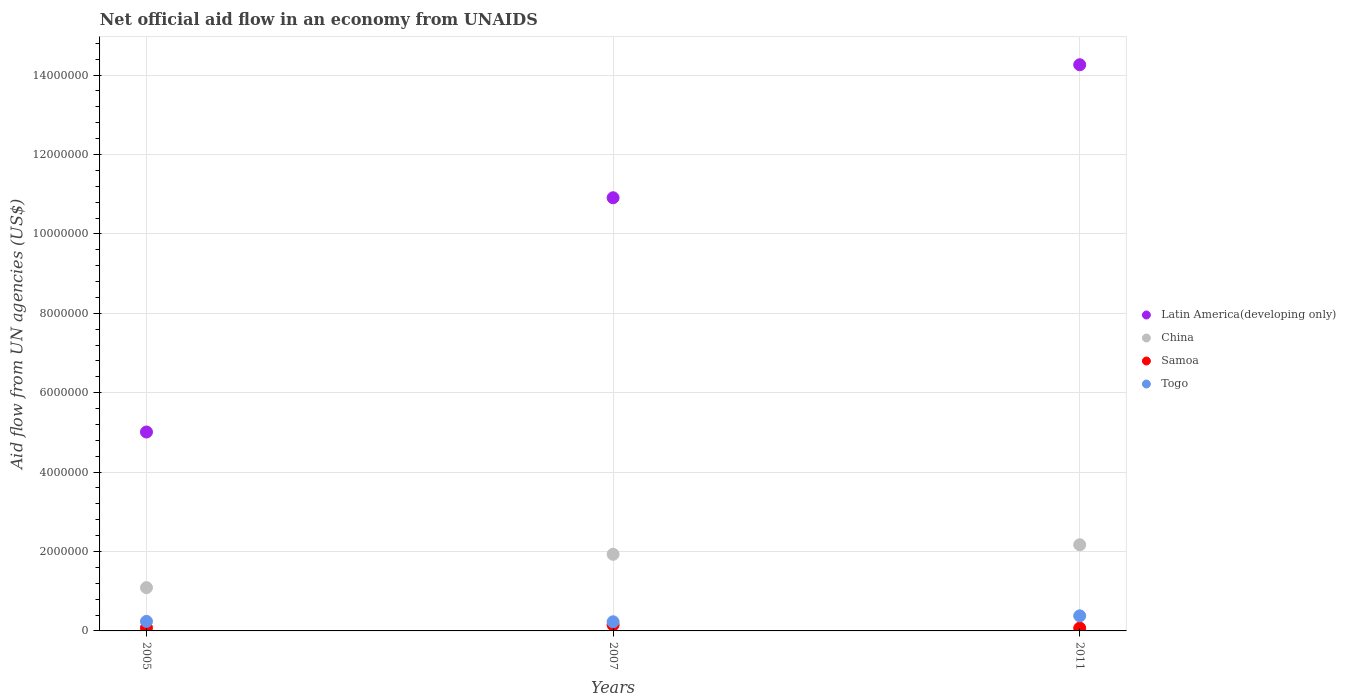How many different coloured dotlines are there?
Offer a terse response. 4. What is the net official aid flow in Latin America(developing only) in 2007?
Your answer should be very brief. 1.09e+07. Across all years, what is the maximum net official aid flow in China?
Your response must be concise. 2.17e+06. Across all years, what is the minimum net official aid flow in Togo?
Give a very brief answer. 2.30e+05. In which year was the net official aid flow in Latin America(developing only) minimum?
Provide a short and direct response. 2005. What is the total net official aid flow in Latin America(developing only) in the graph?
Your answer should be compact. 3.02e+07. What is the difference between the net official aid flow in Togo in 2007 and that in 2011?
Provide a succinct answer. -1.50e+05. What is the difference between the net official aid flow in China in 2011 and the net official aid flow in Togo in 2007?
Ensure brevity in your answer.  1.94e+06. What is the average net official aid flow in China per year?
Your answer should be very brief. 1.73e+06. In the year 2005, what is the difference between the net official aid flow in Togo and net official aid flow in Latin America(developing only)?
Your answer should be very brief. -4.77e+06. In how many years, is the net official aid flow in Samoa greater than 13200000 US$?
Offer a very short reply. 0. What is the ratio of the net official aid flow in Samoa in 2005 to that in 2011?
Your response must be concise. 1.14. Is the difference between the net official aid flow in Togo in 2007 and 2011 greater than the difference between the net official aid flow in Latin America(developing only) in 2007 and 2011?
Provide a short and direct response. Yes. What is the difference between the highest and the second highest net official aid flow in Latin America(developing only)?
Offer a very short reply. 3.35e+06. What is the difference between the highest and the lowest net official aid flow in Latin America(developing only)?
Offer a terse response. 9.25e+06. In how many years, is the net official aid flow in China greater than the average net official aid flow in China taken over all years?
Offer a very short reply. 2. Is it the case that in every year, the sum of the net official aid flow in Samoa and net official aid flow in Togo  is greater than the sum of net official aid flow in Latin America(developing only) and net official aid flow in China?
Ensure brevity in your answer.  No. Is it the case that in every year, the sum of the net official aid flow in Latin America(developing only) and net official aid flow in China  is greater than the net official aid flow in Samoa?
Give a very brief answer. Yes. Is the net official aid flow in Samoa strictly greater than the net official aid flow in Latin America(developing only) over the years?
Provide a short and direct response. No. How many years are there in the graph?
Ensure brevity in your answer.  3. What is the difference between two consecutive major ticks on the Y-axis?
Make the answer very short. 2.00e+06. Does the graph contain any zero values?
Offer a terse response. No. Does the graph contain grids?
Provide a short and direct response. Yes. How many legend labels are there?
Make the answer very short. 4. How are the legend labels stacked?
Give a very brief answer. Vertical. What is the title of the graph?
Your response must be concise. Net official aid flow in an economy from UNAIDS. What is the label or title of the X-axis?
Offer a very short reply. Years. What is the label or title of the Y-axis?
Make the answer very short. Aid flow from UN agencies (US$). What is the Aid flow from UN agencies (US$) of Latin America(developing only) in 2005?
Make the answer very short. 5.01e+06. What is the Aid flow from UN agencies (US$) of China in 2005?
Provide a short and direct response. 1.09e+06. What is the Aid flow from UN agencies (US$) in Togo in 2005?
Give a very brief answer. 2.40e+05. What is the Aid flow from UN agencies (US$) in Latin America(developing only) in 2007?
Give a very brief answer. 1.09e+07. What is the Aid flow from UN agencies (US$) of China in 2007?
Offer a terse response. 1.93e+06. What is the Aid flow from UN agencies (US$) of Samoa in 2007?
Offer a terse response. 1.50e+05. What is the Aid flow from UN agencies (US$) of Latin America(developing only) in 2011?
Your answer should be very brief. 1.43e+07. What is the Aid flow from UN agencies (US$) of China in 2011?
Your answer should be very brief. 2.17e+06. Across all years, what is the maximum Aid flow from UN agencies (US$) in Latin America(developing only)?
Make the answer very short. 1.43e+07. Across all years, what is the maximum Aid flow from UN agencies (US$) of China?
Keep it short and to the point. 2.17e+06. Across all years, what is the maximum Aid flow from UN agencies (US$) of Samoa?
Make the answer very short. 1.50e+05. Across all years, what is the maximum Aid flow from UN agencies (US$) of Togo?
Your answer should be compact. 3.80e+05. Across all years, what is the minimum Aid flow from UN agencies (US$) of Latin America(developing only)?
Your answer should be very brief. 5.01e+06. Across all years, what is the minimum Aid flow from UN agencies (US$) in China?
Offer a very short reply. 1.09e+06. Across all years, what is the minimum Aid flow from UN agencies (US$) of Samoa?
Offer a terse response. 7.00e+04. Across all years, what is the minimum Aid flow from UN agencies (US$) in Togo?
Provide a short and direct response. 2.30e+05. What is the total Aid flow from UN agencies (US$) in Latin America(developing only) in the graph?
Your answer should be very brief. 3.02e+07. What is the total Aid flow from UN agencies (US$) of China in the graph?
Provide a short and direct response. 5.19e+06. What is the total Aid flow from UN agencies (US$) in Samoa in the graph?
Make the answer very short. 3.00e+05. What is the total Aid flow from UN agencies (US$) in Togo in the graph?
Your response must be concise. 8.50e+05. What is the difference between the Aid flow from UN agencies (US$) in Latin America(developing only) in 2005 and that in 2007?
Provide a short and direct response. -5.90e+06. What is the difference between the Aid flow from UN agencies (US$) in China in 2005 and that in 2007?
Offer a terse response. -8.40e+05. What is the difference between the Aid flow from UN agencies (US$) in Togo in 2005 and that in 2007?
Give a very brief answer. 10000. What is the difference between the Aid flow from UN agencies (US$) in Latin America(developing only) in 2005 and that in 2011?
Your answer should be compact. -9.25e+06. What is the difference between the Aid flow from UN agencies (US$) in China in 2005 and that in 2011?
Keep it short and to the point. -1.08e+06. What is the difference between the Aid flow from UN agencies (US$) of Togo in 2005 and that in 2011?
Your response must be concise. -1.40e+05. What is the difference between the Aid flow from UN agencies (US$) of Latin America(developing only) in 2007 and that in 2011?
Provide a succinct answer. -3.35e+06. What is the difference between the Aid flow from UN agencies (US$) in Latin America(developing only) in 2005 and the Aid flow from UN agencies (US$) in China in 2007?
Keep it short and to the point. 3.08e+06. What is the difference between the Aid flow from UN agencies (US$) in Latin America(developing only) in 2005 and the Aid flow from UN agencies (US$) in Samoa in 2007?
Your answer should be very brief. 4.86e+06. What is the difference between the Aid flow from UN agencies (US$) in Latin America(developing only) in 2005 and the Aid flow from UN agencies (US$) in Togo in 2007?
Make the answer very short. 4.78e+06. What is the difference between the Aid flow from UN agencies (US$) in China in 2005 and the Aid flow from UN agencies (US$) in Samoa in 2007?
Offer a very short reply. 9.40e+05. What is the difference between the Aid flow from UN agencies (US$) in China in 2005 and the Aid flow from UN agencies (US$) in Togo in 2007?
Your answer should be very brief. 8.60e+05. What is the difference between the Aid flow from UN agencies (US$) of Samoa in 2005 and the Aid flow from UN agencies (US$) of Togo in 2007?
Your answer should be compact. -1.50e+05. What is the difference between the Aid flow from UN agencies (US$) in Latin America(developing only) in 2005 and the Aid flow from UN agencies (US$) in China in 2011?
Give a very brief answer. 2.84e+06. What is the difference between the Aid flow from UN agencies (US$) in Latin America(developing only) in 2005 and the Aid flow from UN agencies (US$) in Samoa in 2011?
Offer a terse response. 4.94e+06. What is the difference between the Aid flow from UN agencies (US$) in Latin America(developing only) in 2005 and the Aid flow from UN agencies (US$) in Togo in 2011?
Your answer should be very brief. 4.63e+06. What is the difference between the Aid flow from UN agencies (US$) of China in 2005 and the Aid flow from UN agencies (US$) of Samoa in 2011?
Ensure brevity in your answer.  1.02e+06. What is the difference between the Aid flow from UN agencies (US$) of China in 2005 and the Aid flow from UN agencies (US$) of Togo in 2011?
Keep it short and to the point. 7.10e+05. What is the difference between the Aid flow from UN agencies (US$) in Samoa in 2005 and the Aid flow from UN agencies (US$) in Togo in 2011?
Keep it short and to the point. -3.00e+05. What is the difference between the Aid flow from UN agencies (US$) in Latin America(developing only) in 2007 and the Aid flow from UN agencies (US$) in China in 2011?
Provide a short and direct response. 8.74e+06. What is the difference between the Aid flow from UN agencies (US$) in Latin America(developing only) in 2007 and the Aid flow from UN agencies (US$) in Samoa in 2011?
Offer a very short reply. 1.08e+07. What is the difference between the Aid flow from UN agencies (US$) of Latin America(developing only) in 2007 and the Aid flow from UN agencies (US$) of Togo in 2011?
Ensure brevity in your answer.  1.05e+07. What is the difference between the Aid flow from UN agencies (US$) of China in 2007 and the Aid flow from UN agencies (US$) of Samoa in 2011?
Give a very brief answer. 1.86e+06. What is the difference between the Aid flow from UN agencies (US$) in China in 2007 and the Aid flow from UN agencies (US$) in Togo in 2011?
Your response must be concise. 1.55e+06. What is the difference between the Aid flow from UN agencies (US$) of Samoa in 2007 and the Aid flow from UN agencies (US$) of Togo in 2011?
Provide a short and direct response. -2.30e+05. What is the average Aid flow from UN agencies (US$) in Latin America(developing only) per year?
Provide a succinct answer. 1.01e+07. What is the average Aid flow from UN agencies (US$) of China per year?
Make the answer very short. 1.73e+06. What is the average Aid flow from UN agencies (US$) of Togo per year?
Provide a short and direct response. 2.83e+05. In the year 2005, what is the difference between the Aid flow from UN agencies (US$) in Latin America(developing only) and Aid flow from UN agencies (US$) in China?
Ensure brevity in your answer.  3.92e+06. In the year 2005, what is the difference between the Aid flow from UN agencies (US$) of Latin America(developing only) and Aid flow from UN agencies (US$) of Samoa?
Offer a very short reply. 4.93e+06. In the year 2005, what is the difference between the Aid flow from UN agencies (US$) in Latin America(developing only) and Aid flow from UN agencies (US$) in Togo?
Your answer should be very brief. 4.77e+06. In the year 2005, what is the difference between the Aid flow from UN agencies (US$) of China and Aid flow from UN agencies (US$) of Samoa?
Provide a short and direct response. 1.01e+06. In the year 2005, what is the difference between the Aid flow from UN agencies (US$) in China and Aid flow from UN agencies (US$) in Togo?
Give a very brief answer. 8.50e+05. In the year 2005, what is the difference between the Aid flow from UN agencies (US$) in Samoa and Aid flow from UN agencies (US$) in Togo?
Keep it short and to the point. -1.60e+05. In the year 2007, what is the difference between the Aid flow from UN agencies (US$) in Latin America(developing only) and Aid flow from UN agencies (US$) in China?
Ensure brevity in your answer.  8.98e+06. In the year 2007, what is the difference between the Aid flow from UN agencies (US$) in Latin America(developing only) and Aid flow from UN agencies (US$) in Samoa?
Keep it short and to the point. 1.08e+07. In the year 2007, what is the difference between the Aid flow from UN agencies (US$) of Latin America(developing only) and Aid flow from UN agencies (US$) of Togo?
Ensure brevity in your answer.  1.07e+07. In the year 2007, what is the difference between the Aid flow from UN agencies (US$) in China and Aid flow from UN agencies (US$) in Samoa?
Offer a terse response. 1.78e+06. In the year 2007, what is the difference between the Aid flow from UN agencies (US$) of China and Aid flow from UN agencies (US$) of Togo?
Offer a terse response. 1.70e+06. In the year 2011, what is the difference between the Aid flow from UN agencies (US$) of Latin America(developing only) and Aid flow from UN agencies (US$) of China?
Give a very brief answer. 1.21e+07. In the year 2011, what is the difference between the Aid flow from UN agencies (US$) of Latin America(developing only) and Aid flow from UN agencies (US$) of Samoa?
Give a very brief answer. 1.42e+07. In the year 2011, what is the difference between the Aid flow from UN agencies (US$) of Latin America(developing only) and Aid flow from UN agencies (US$) of Togo?
Provide a short and direct response. 1.39e+07. In the year 2011, what is the difference between the Aid flow from UN agencies (US$) in China and Aid flow from UN agencies (US$) in Samoa?
Provide a short and direct response. 2.10e+06. In the year 2011, what is the difference between the Aid flow from UN agencies (US$) of China and Aid flow from UN agencies (US$) of Togo?
Keep it short and to the point. 1.79e+06. In the year 2011, what is the difference between the Aid flow from UN agencies (US$) of Samoa and Aid flow from UN agencies (US$) of Togo?
Offer a very short reply. -3.10e+05. What is the ratio of the Aid flow from UN agencies (US$) of Latin America(developing only) in 2005 to that in 2007?
Provide a succinct answer. 0.46. What is the ratio of the Aid flow from UN agencies (US$) in China in 2005 to that in 2007?
Provide a succinct answer. 0.56. What is the ratio of the Aid flow from UN agencies (US$) of Samoa in 2005 to that in 2007?
Your answer should be compact. 0.53. What is the ratio of the Aid flow from UN agencies (US$) in Togo in 2005 to that in 2007?
Make the answer very short. 1.04. What is the ratio of the Aid flow from UN agencies (US$) of Latin America(developing only) in 2005 to that in 2011?
Provide a succinct answer. 0.35. What is the ratio of the Aid flow from UN agencies (US$) in China in 2005 to that in 2011?
Your answer should be very brief. 0.5. What is the ratio of the Aid flow from UN agencies (US$) in Samoa in 2005 to that in 2011?
Your answer should be compact. 1.14. What is the ratio of the Aid flow from UN agencies (US$) in Togo in 2005 to that in 2011?
Provide a short and direct response. 0.63. What is the ratio of the Aid flow from UN agencies (US$) of Latin America(developing only) in 2007 to that in 2011?
Give a very brief answer. 0.77. What is the ratio of the Aid flow from UN agencies (US$) of China in 2007 to that in 2011?
Your response must be concise. 0.89. What is the ratio of the Aid flow from UN agencies (US$) in Samoa in 2007 to that in 2011?
Offer a very short reply. 2.14. What is the ratio of the Aid flow from UN agencies (US$) in Togo in 2007 to that in 2011?
Provide a short and direct response. 0.61. What is the difference between the highest and the second highest Aid flow from UN agencies (US$) of Latin America(developing only)?
Offer a very short reply. 3.35e+06. What is the difference between the highest and the second highest Aid flow from UN agencies (US$) in Samoa?
Ensure brevity in your answer.  7.00e+04. What is the difference between the highest and the lowest Aid flow from UN agencies (US$) of Latin America(developing only)?
Your response must be concise. 9.25e+06. What is the difference between the highest and the lowest Aid flow from UN agencies (US$) in China?
Offer a terse response. 1.08e+06. What is the difference between the highest and the lowest Aid flow from UN agencies (US$) in Samoa?
Your answer should be compact. 8.00e+04. 